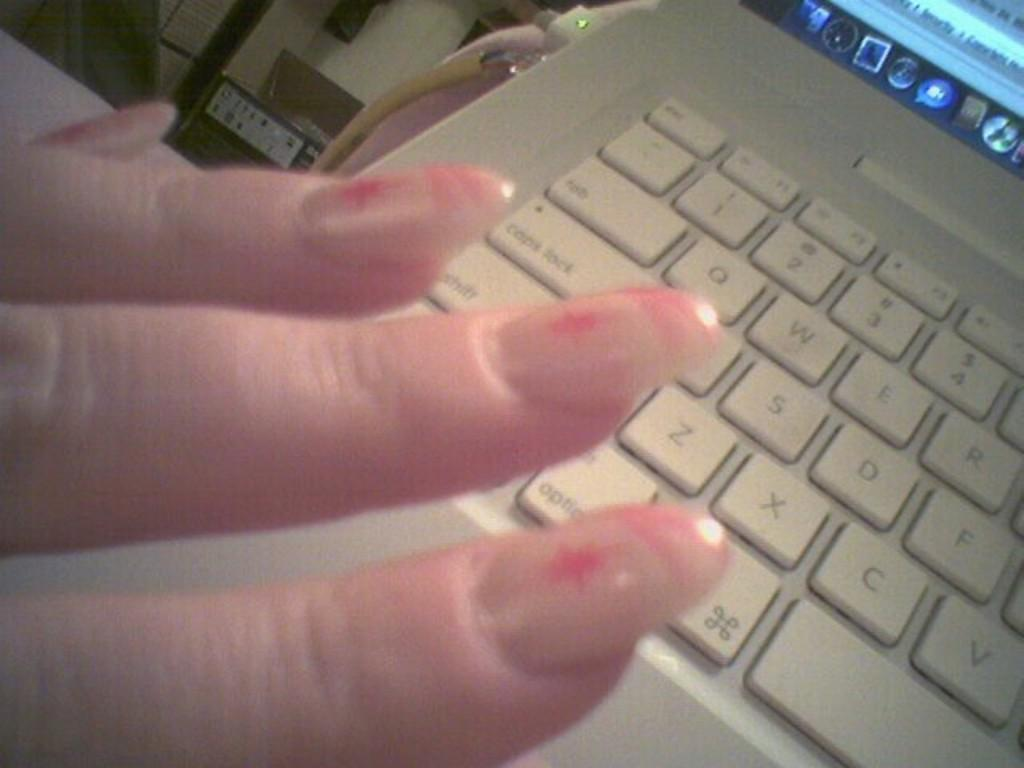<image>
Give a short and clear explanation of the subsequent image. The C, V and F keys, among others, are visible on a computer keyboard. 